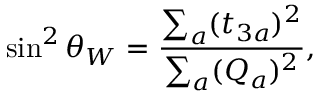<formula> <loc_0><loc_0><loc_500><loc_500>\sin ^ { 2 } \theta _ { W } = \frac { \sum _ { a } ( t _ { 3 a } ) ^ { 2 } } { \sum _ { a } ( Q _ { a } ) ^ { 2 } } ,</formula> 